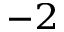<formula> <loc_0><loc_0><loc_500><loc_500>^ { - 2 }</formula> 